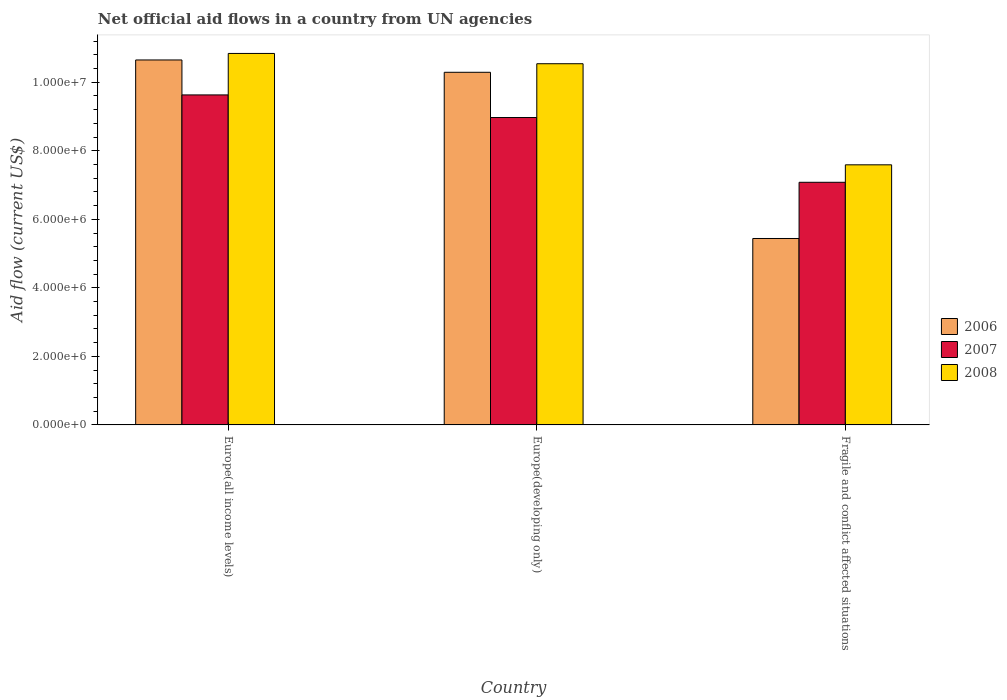How many different coloured bars are there?
Offer a terse response. 3. How many groups of bars are there?
Offer a very short reply. 3. Are the number of bars per tick equal to the number of legend labels?
Offer a terse response. Yes. Are the number of bars on each tick of the X-axis equal?
Offer a terse response. Yes. How many bars are there on the 3rd tick from the right?
Your answer should be compact. 3. What is the label of the 1st group of bars from the left?
Your response must be concise. Europe(all income levels). In how many cases, is the number of bars for a given country not equal to the number of legend labels?
Make the answer very short. 0. What is the net official aid flow in 2008 in Europe(all income levels)?
Offer a terse response. 1.08e+07. Across all countries, what is the maximum net official aid flow in 2007?
Ensure brevity in your answer.  9.63e+06. Across all countries, what is the minimum net official aid flow in 2007?
Give a very brief answer. 7.08e+06. In which country was the net official aid flow in 2007 maximum?
Offer a terse response. Europe(all income levels). In which country was the net official aid flow in 2007 minimum?
Keep it short and to the point. Fragile and conflict affected situations. What is the total net official aid flow in 2006 in the graph?
Offer a very short reply. 2.64e+07. What is the difference between the net official aid flow in 2008 in Europe(developing only) and that in Fragile and conflict affected situations?
Provide a short and direct response. 2.95e+06. What is the difference between the net official aid flow in 2008 in Fragile and conflict affected situations and the net official aid flow in 2007 in Europe(all income levels)?
Provide a short and direct response. -2.04e+06. What is the average net official aid flow in 2006 per country?
Give a very brief answer. 8.79e+06. What is the difference between the net official aid flow of/in 2008 and net official aid flow of/in 2007 in Europe(all income levels)?
Provide a succinct answer. 1.21e+06. In how many countries, is the net official aid flow in 2006 greater than 7600000 US$?
Keep it short and to the point. 2. What is the ratio of the net official aid flow in 2006 in Europe(all income levels) to that in Fragile and conflict affected situations?
Your response must be concise. 1.96. Is the net official aid flow in 2008 in Europe(all income levels) less than that in Europe(developing only)?
Ensure brevity in your answer.  No. Is the difference between the net official aid flow in 2008 in Europe(all income levels) and Fragile and conflict affected situations greater than the difference between the net official aid flow in 2007 in Europe(all income levels) and Fragile and conflict affected situations?
Ensure brevity in your answer.  Yes. What is the difference between the highest and the second highest net official aid flow in 2008?
Your answer should be very brief. 3.25e+06. What is the difference between the highest and the lowest net official aid flow in 2008?
Make the answer very short. 3.25e+06. In how many countries, is the net official aid flow in 2008 greater than the average net official aid flow in 2008 taken over all countries?
Ensure brevity in your answer.  2. Is the sum of the net official aid flow in 2007 in Europe(all income levels) and Fragile and conflict affected situations greater than the maximum net official aid flow in 2008 across all countries?
Offer a very short reply. Yes. What does the 1st bar from the left in Europe(all income levels) represents?
Offer a very short reply. 2006. What does the 3rd bar from the right in Europe(developing only) represents?
Ensure brevity in your answer.  2006. Is it the case that in every country, the sum of the net official aid flow in 2007 and net official aid flow in 2008 is greater than the net official aid flow in 2006?
Your answer should be compact. Yes. How many bars are there?
Provide a succinct answer. 9. Are all the bars in the graph horizontal?
Your answer should be compact. No. How many countries are there in the graph?
Your response must be concise. 3. Are the values on the major ticks of Y-axis written in scientific E-notation?
Provide a short and direct response. Yes. How are the legend labels stacked?
Make the answer very short. Vertical. What is the title of the graph?
Ensure brevity in your answer.  Net official aid flows in a country from UN agencies. What is the Aid flow (current US$) of 2006 in Europe(all income levels)?
Make the answer very short. 1.06e+07. What is the Aid flow (current US$) of 2007 in Europe(all income levels)?
Provide a short and direct response. 9.63e+06. What is the Aid flow (current US$) of 2008 in Europe(all income levels)?
Give a very brief answer. 1.08e+07. What is the Aid flow (current US$) in 2006 in Europe(developing only)?
Keep it short and to the point. 1.03e+07. What is the Aid flow (current US$) of 2007 in Europe(developing only)?
Offer a very short reply. 8.97e+06. What is the Aid flow (current US$) of 2008 in Europe(developing only)?
Give a very brief answer. 1.05e+07. What is the Aid flow (current US$) of 2006 in Fragile and conflict affected situations?
Offer a very short reply. 5.44e+06. What is the Aid flow (current US$) of 2007 in Fragile and conflict affected situations?
Offer a terse response. 7.08e+06. What is the Aid flow (current US$) in 2008 in Fragile and conflict affected situations?
Ensure brevity in your answer.  7.59e+06. Across all countries, what is the maximum Aid flow (current US$) of 2006?
Your answer should be very brief. 1.06e+07. Across all countries, what is the maximum Aid flow (current US$) in 2007?
Your answer should be very brief. 9.63e+06. Across all countries, what is the maximum Aid flow (current US$) of 2008?
Keep it short and to the point. 1.08e+07. Across all countries, what is the minimum Aid flow (current US$) in 2006?
Your response must be concise. 5.44e+06. Across all countries, what is the minimum Aid flow (current US$) of 2007?
Ensure brevity in your answer.  7.08e+06. Across all countries, what is the minimum Aid flow (current US$) of 2008?
Your response must be concise. 7.59e+06. What is the total Aid flow (current US$) in 2006 in the graph?
Make the answer very short. 2.64e+07. What is the total Aid flow (current US$) of 2007 in the graph?
Your response must be concise. 2.57e+07. What is the total Aid flow (current US$) in 2008 in the graph?
Provide a succinct answer. 2.90e+07. What is the difference between the Aid flow (current US$) of 2006 in Europe(all income levels) and that in Fragile and conflict affected situations?
Provide a short and direct response. 5.21e+06. What is the difference between the Aid flow (current US$) in 2007 in Europe(all income levels) and that in Fragile and conflict affected situations?
Offer a very short reply. 2.55e+06. What is the difference between the Aid flow (current US$) in 2008 in Europe(all income levels) and that in Fragile and conflict affected situations?
Your answer should be compact. 3.25e+06. What is the difference between the Aid flow (current US$) of 2006 in Europe(developing only) and that in Fragile and conflict affected situations?
Make the answer very short. 4.85e+06. What is the difference between the Aid flow (current US$) of 2007 in Europe(developing only) and that in Fragile and conflict affected situations?
Your answer should be very brief. 1.89e+06. What is the difference between the Aid flow (current US$) of 2008 in Europe(developing only) and that in Fragile and conflict affected situations?
Your answer should be very brief. 2.95e+06. What is the difference between the Aid flow (current US$) in 2006 in Europe(all income levels) and the Aid flow (current US$) in 2007 in Europe(developing only)?
Ensure brevity in your answer.  1.68e+06. What is the difference between the Aid flow (current US$) of 2007 in Europe(all income levels) and the Aid flow (current US$) of 2008 in Europe(developing only)?
Ensure brevity in your answer.  -9.10e+05. What is the difference between the Aid flow (current US$) of 2006 in Europe(all income levels) and the Aid flow (current US$) of 2007 in Fragile and conflict affected situations?
Provide a succinct answer. 3.57e+06. What is the difference between the Aid flow (current US$) of 2006 in Europe(all income levels) and the Aid flow (current US$) of 2008 in Fragile and conflict affected situations?
Ensure brevity in your answer.  3.06e+06. What is the difference between the Aid flow (current US$) of 2007 in Europe(all income levels) and the Aid flow (current US$) of 2008 in Fragile and conflict affected situations?
Offer a very short reply. 2.04e+06. What is the difference between the Aid flow (current US$) in 2006 in Europe(developing only) and the Aid flow (current US$) in 2007 in Fragile and conflict affected situations?
Offer a very short reply. 3.21e+06. What is the difference between the Aid flow (current US$) of 2006 in Europe(developing only) and the Aid flow (current US$) of 2008 in Fragile and conflict affected situations?
Make the answer very short. 2.70e+06. What is the difference between the Aid flow (current US$) of 2007 in Europe(developing only) and the Aid flow (current US$) of 2008 in Fragile and conflict affected situations?
Your answer should be very brief. 1.38e+06. What is the average Aid flow (current US$) of 2006 per country?
Give a very brief answer. 8.79e+06. What is the average Aid flow (current US$) in 2007 per country?
Provide a short and direct response. 8.56e+06. What is the average Aid flow (current US$) of 2008 per country?
Give a very brief answer. 9.66e+06. What is the difference between the Aid flow (current US$) in 2006 and Aid flow (current US$) in 2007 in Europe(all income levels)?
Your response must be concise. 1.02e+06. What is the difference between the Aid flow (current US$) in 2006 and Aid flow (current US$) in 2008 in Europe(all income levels)?
Offer a terse response. -1.90e+05. What is the difference between the Aid flow (current US$) of 2007 and Aid flow (current US$) of 2008 in Europe(all income levels)?
Offer a terse response. -1.21e+06. What is the difference between the Aid flow (current US$) in 2006 and Aid flow (current US$) in 2007 in Europe(developing only)?
Your answer should be very brief. 1.32e+06. What is the difference between the Aid flow (current US$) of 2006 and Aid flow (current US$) of 2008 in Europe(developing only)?
Give a very brief answer. -2.50e+05. What is the difference between the Aid flow (current US$) in 2007 and Aid flow (current US$) in 2008 in Europe(developing only)?
Offer a very short reply. -1.57e+06. What is the difference between the Aid flow (current US$) of 2006 and Aid flow (current US$) of 2007 in Fragile and conflict affected situations?
Your response must be concise. -1.64e+06. What is the difference between the Aid flow (current US$) of 2006 and Aid flow (current US$) of 2008 in Fragile and conflict affected situations?
Ensure brevity in your answer.  -2.15e+06. What is the difference between the Aid flow (current US$) in 2007 and Aid flow (current US$) in 2008 in Fragile and conflict affected situations?
Give a very brief answer. -5.10e+05. What is the ratio of the Aid flow (current US$) of 2006 in Europe(all income levels) to that in Europe(developing only)?
Keep it short and to the point. 1.03. What is the ratio of the Aid flow (current US$) of 2007 in Europe(all income levels) to that in Europe(developing only)?
Provide a short and direct response. 1.07. What is the ratio of the Aid flow (current US$) in 2008 in Europe(all income levels) to that in Europe(developing only)?
Provide a short and direct response. 1.03. What is the ratio of the Aid flow (current US$) in 2006 in Europe(all income levels) to that in Fragile and conflict affected situations?
Give a very brief answer. 1.96. What is the ratio of the Aid flow (current US$) of 2007 in Europe(all income levels) to that in Fragile and conflict affected situations?
Your answer should be compact. 1.36. What is the ratio of the Aid flow (current US$) in 2008 in Europe(all income levels) to that in Fragile and conflict affected situations?
Offer a terse response. 1.43. What is the ratio of the Aid flow (current US$) of 2006 in Europe(developing only) to that in Fragile and conflict affected situations?
Your response must be concise. 1.89. What is the ratio of the Aid flow (current US$) of 2007 in Europe(developing only) to that in Fragile and conflict affected situations?
Make the answer very short. 1.27. What is the ratio of the Aid flow (current US$) of 2008 in Europe(developing only) to that in Fragile and conflict affected situations?
Offer a terse response. 1.39. What is the difference between the highest and the second highest Aid flow (current US$) of 2007?
Give a very brief answer. 6.60e+05. What is the difference between the highest and the lowest Aid flow (current US$) in 2006?
Make the answer very short. 5.21e+06. What is the difference between the highest and the lowest Aid flow (current US$) of 2007?
Provide a succinct answer. 2.55e+06. What is the difference between the highest and the lowest Aid flow (current US$) of 2008?
Give a very brief answer. 3.25e+06. 